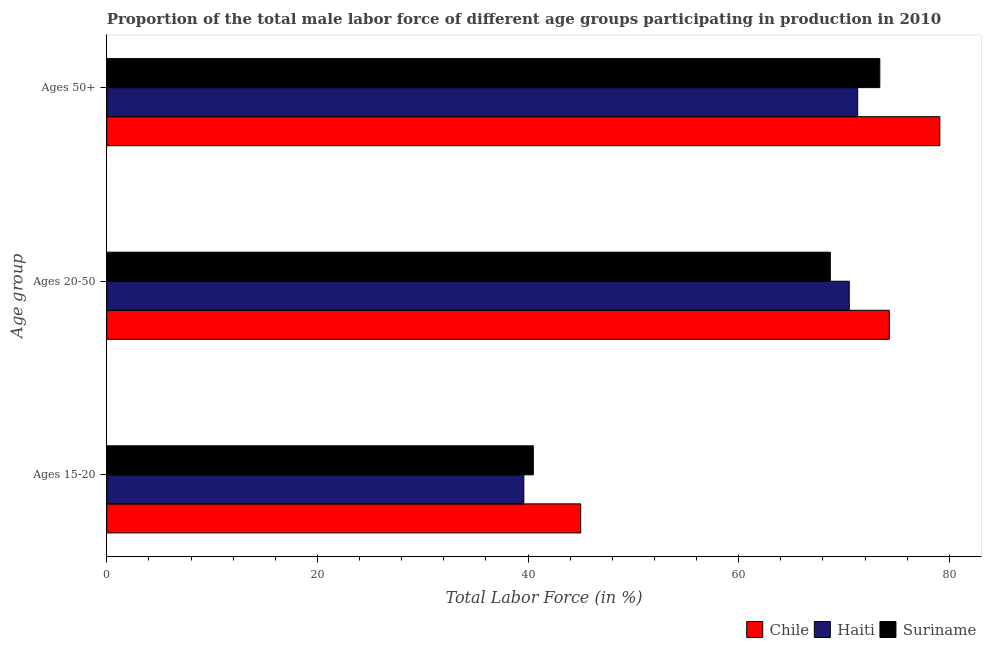How many groups of bars are there?
Your answer should be compact. 3. Are the number of bars on each tick of the Y-axis equal?
Offer a very short reply. Yes. How many bars are there on the 1st tick from the top?
Your answer should be compact. 3. What is the label of the 3rd group of bars from the top?
Ensure brevity in your answer.  Ages 15-20. What is the percentage of male labor force within the age group 15-20 in Chile?
Provide a short and direct response. 45. Across all countries, what is the minimum percentage of male labor force within the age group 15-20?
Offer a terse response. 39.6. In which country was the percentage of male labor force above age 50 maximum?
Offer a very short reply. Chile. In which country was the percentage of male labor force within the age group 15-20 minimum?
Offer a terse response. Haiti. What is the total percentage of male labor force within the age group 20-50 in the graph?
Ensure brevity in your answer.  213.5. What is the difference between the percentage of male labor force above age 50 in Suriname and that in Haiti?
Your answer should be compact. 2.1. What is the average percentage of male labor force within the age group 15-20 per country?
Offer a very short reply. 41.7. What is the difference between the percentage of male labor force above age 50 and percentage of male labor force within the age group 15-20 in Chile?
Your response must be concise. 34.1. In how many countries, is the percentage of male labor force within the age group 20-50 greater than 24 %?
Your answer should be compact. 3. What is the ratio of the percentage of male labor force within the age group 20-50 in Suriname to that in Chile?
Keep it short and to the point. 0.92. Is the percentage of male labor force within the age group 15-20 in Suriname less than that in Haiti?
Make the answer very short. No. Is the difference between the percentage of male labor force within the age group 15-20 in Chile and Haiti greater than the difference between the percentage of male labor force above age 50 in Chile and Haiti?
Offer a terse response. No. What is the difference between the highest and the second highest percentage of male labor force within the age group 15-20?
Your response must be concise. 4.5. What is the difference between the highest and the lowest percentage of male labor force above age 50?
Ensure brevity in your answer.  7.8. In how many countries, is the percentage of male labor force above age 50 greater than the average percentage of male labor force above age 50 taken over all countries?
Your answer should be very brief. 1. What does the 3rd bar from the top in Ages 15-20 represents?
Offer a very short reply. Chile. What does the 1st bar from the bottom in Ages 50+ represents?
Give a very brief answer. Chile. Is it the case that in every country, the sum of the percentage of male labor force within the age group 15-20 and percentage of male labor force within the age group 20-50 is greater than the percentage of male labor force above age 50?
Give a very brief answer. Yes. Are the values on the major ticks of X-axis written in scientific E-notation?
Your response must be concise. No. How many legend labels are there?
Provide a short and direct response. 3. What is the title of the graph?
Offer a terse response. Proportion of the total male labor force of different age groups participating in production in 2010. What is the label or title of the X-axis?
Provide a succinct answer. Total Labor Force (in %). What is the label or title of the Y-axis?
Ensure brevity in your answer.  Age group. What is the Total Labor Force (in %) in Haiti in Ages 15-20?
Give a very brief answer. 39.6. What is the Total Labor Force (in %) in Suriname in Ages 15-20?
Your response must be concise. 40.5. What is the Total Labor Force (in %) in Chile in Ages 20-50?
Offer a terse response. 74.3. What is the Total Labor Force (in %) of Haiti in Ages 20-50?
Ensure brevity in your answer.  70.5. What is the Total Labor Force (in %) of Suriname in Ages 20-50?
Give a very brief answer. 68.7. What is the Total Labor Force (in %) in Chile in Ages 50+?
Your answer should be compact. 79.1. What is the Total Labor Force (in %) in Haiti in Ages 50+?
Offer a terse response. 71.3. What is the Total Labor Force (in %) in Suriname in Ages 50+?
Make the answer very short. 73.4. Across all Age group, what is the maximum Total Labor Force (in %) of Chile?
Your answer should be compact. 79.1. Across all Age group, what is the maximum Total Labor Force (in %) of Haiti?
Give a very brief answer. 71.3. Across all Age group, what is the maximum Total Labor Force (in %) in Suriname?
Your answer should be compact. 73.4. Across all Age group, what is the minimum Total Labor Force (in %) in Haiti?
Keep it short and to the point. 39.6. Across all Age group, what is the minimum Total Labor Force (in %) of Suriname?
Keep it short and to the point. 40.5. What is the total Total Labor Force (in %) of Chile in the graph?
Your answer should be very brief. 198.4. What is the total Total Labor Force (in %) of Haiti in the graph?
Give a very brief answer. 181.4. What is the total Total Labor Force (in %) in Suriname in the graph?
Give a very brief answer. 182.6. What is the difference between the Total Labor Force (in %) in Chile in Ages 15-20 and that in Ages 20-50?
Make the answer very short. -29.3. What is the difference between the Total Labor Force (in %) in Haiti in Ages 15-20 and that in Ages 20-50?
Provide a short and direct response. -30.9. What is the difference between the Total Labor Force (in %) in Suriname in Ages 15-20 and that in Ages 20-50?
Offer a very short reply. -28.2. What is the difference between the Total Labor Force (in %) in Chile in Ages 15-20 and that in Ages 50+?
Ensure brevity in your answer.  -34.1. What is the difference between the Total Labor Force (in %) in Haiti in Ages 15-20 and that in Ages 50+?
Your answer should be very brief. -31.7. What is the difference between the Total Labor Force (in %) in Suriname in Ages 15-20 and that in Ages 50+?
Offer a terse response. -32.9. What is the difference between the Total Labor Force (in %) of Haiti in Ages 20-50 and that in Ages 50+?
Provide a succinct answer. -0.8. What is the difference between the Total Labor Force (in %) in Suriname in Ages 20-50 and that in Ages 50+?
Make the answer very short. -4.7. What is the difference between the Total Labor Force (in %) of Chile in Ages 15-20 and the Total Labor Force (in %) of Haiti in Ages 20-50?
Ensure brevity in your answer.  -25.5. What is the difference between the Total Labor Force (in %) in Chile in Ages 15-20 and the Total Labor Force (in %) in Suriname in Ages 20-50?
Keep it short and to the point. -23.7. What is the difference between the Total Labor Force (in %) in Haiti in Ages 15-20 and the Total Labor Force (in %) in Suriname in Ages 20-50?
Provide a short and direct response. -29.1. What is the difference between the Total Labor Force (in %) of Chile in Ages 15-20 and the Total Labor Force (in %) of Haiti in Ages 50+?
Your answer should be compact. -26.3. What is the difference between the Total Labor Force (in %) of Chile in Ages 15-20 and the Total Labor Force (in %) of Suriname in Ages 50+?
Provide a short and direct response. -28.4. What is the difference between the Total Labor Force (in %) of Haiti in Ages 15-20 and the Total Labor Force (in %) of Suriname in Ages 50+?
Offer a very short reply. -33.8. What is the difference between the Total Labor Force (in %) in Chile in Ages 20-50 and the Total Labor Force (in %) in Suriname in Ages 50+?
Ensure brevity in your answer.  0.9. What is the average Total Labor Force (in %) of Chile per Age group?
Provide a succinct answer. 66.13. What is the average Total Labor Force (in %) in Haiti per Age group?
Provide a succinct answer. 60.47. What is the average Total Labor Force (in %) of Suriname per Age group?
Provide a short and direct response. 60.87. What is the difference between the Total Labor Force (in %) of Chile and Total Labor Force (in %) of Haiti in Ages 15-20?
Make the answer very short. 5.4. What is the difference between the Total Labor Force (in %) of Chile and Total Labor Force (in %) of Suriname in Ages 15-20?
Make the answer very short. 4.5. What is the difference between the Total Labor Force (in %) in Haiti and Total Labor Force (in %) in Suriname in Ages 15-20?
Provide a succinct answer. -0.9. What is the difference between the Total Labor Force (in %) of Chile and Total Labor Force (in %) of Haiti in Ages 20-50?
Provide a short and direct response. 3.8. What is the difference between the Total Labor Force (in %) in Chile and Total Labor Force (in %) in Suriname in Ages 20-50?
Keep it short and to the point. 5.6. What is the difference between the Total Labor Force (in %) of Haiti and Total Labor Force (in %) of Suriname in Ages 50+?
Provide a short and direct response. -2.1. What is the ratio of the Total Labor Force (in %) in Chile in Ages 15-20 to that in Ages 20-50?
Your response must be concise. 0.61. What is the ratio of the Total Labor Force (in %) of Haiti in Ages 15-20 to that in Ages 20-50?
Offer a terse response. 0.56. What is the ratio of the Total Labor Force (in %) of Suriname in Ages 15-20 to that in Ages 20-50?
Your response must be concise. 0.59. What is the ratio of the Total Labor Force (in %) in Chile in Ages 15-20 to that in Ages 50+?
Give a very brief answer. 0.57. What is the ratio of the Total Labor Force (in %) in Haiti in Ages 15-20 to that in Ages 50+?
Ensure brevity in your answer.  0.56. What is the ratio of the Total Labor Force (in %) in Suriname in Ages 15-20 to that in Ages 50+?
Provide a succinct answer. 0.55. What is the ratio of the Total Labor Force (in %) in Chile in Ages 20-50 to that in Ages 50+?
Make the answer very short. 0.94. What is the ratio of the Total Labor Force (in %) in Suriname in Ages 20-50 to that in Ages 50+?
Make the answer very short. 0.94. What is the difference between the highest and the second highest Total Labor Force (in %) of Haiti?
Your answer should be very brief. 0.8. What is the difference between the highest and the lowest Total Labor Force (in %) in Chile?
Offer a terse response. 34.1. What is the difference between the highest and the lowest Total Labor Force (in %) in Haiti?
Provide a succinct answer. 31.7. What is the difference between the highest and the lowest Total Labor Force (in %) of Suriname?
Provide a short and direct response. 32.9. 